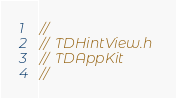<code> <loc_0><loc_0><loc_500><loc_500><_C_>//
//  TDHintView.h
//  TDAppKit
//</code> 